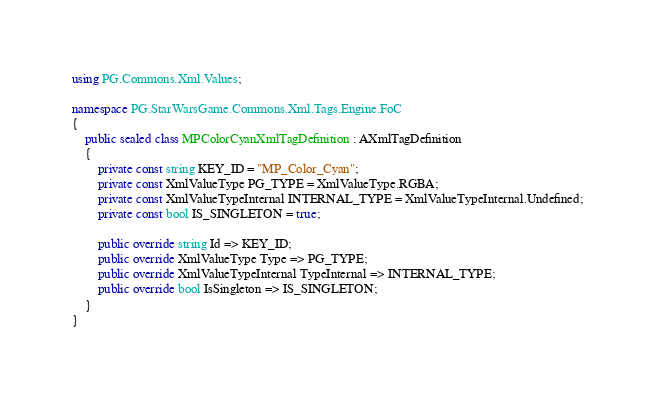<code> <loc_0><loc_0><loc_500><loc_500><_C#_>using PG.Commons.Xml.Values;

namespace PG.StarWarsGame.Commons.Xml.Tags.Engine.FoC
{
    public sealed class MPColorCyanXmlTagDefinition : AXmlTagDefinition
    {
        private const string KEY_ID = "MP_Color_Cyan";
        private const XmlValueType PG_TYPE = XmlValueType.RGBA;
        private const XmlValueTypeInternal INTERNAL_TYPE = XmlValueTypeInternal.Undefined;
        private const bool IS_SINGLETON = true;

        public override string Id => KEY_ID;
        public override XmlValueType Type => PG_TYPE;
        public override XmlValueTypeInternal TypeInternal => INTERNAL_TYPE;
        public override bool IsSingleton => IS_SINGLETON;
    }
}</code> 